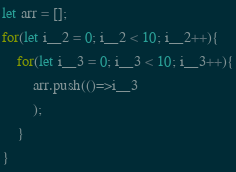<code> <loc_0><loc_0><loc_500><loc_500><_JavaScript_>let arr = [];
for(let i__2 = 0; i__2 < 10; i__2++){
    for(let i__3 = 0; i__3 < 10; i__3++){
        arr.push(()=>i__3
        );
    }
}
</code> 